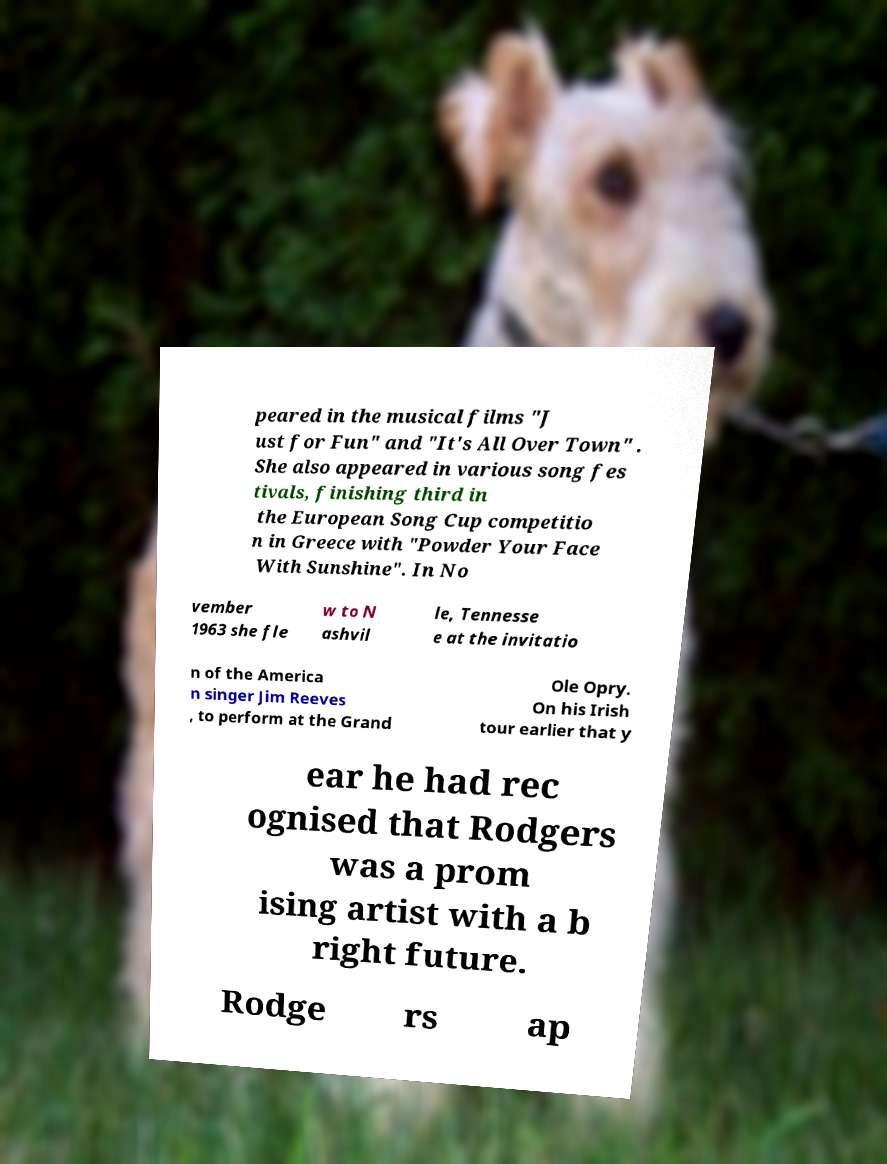Can you accurately transcribe the text from the provided image for me? peared in the musical films "J ust for Fun" and "It's All Over Town" . She also appeared in various song fes tivals, finishing third in the European Song Cup competitio n in Greece with "Powder Your Face With Sunshine". In No vember 1963 she fle w to N ashvil le, Tennesse e at the invitatio n of the America n singer Jim Reeves , to perform at the Grand Ole Opry. On his Irish tour earlier that y ear he had rec ognised that Rodgers was a prom ising artist with a b right future. Rodge rs ap 